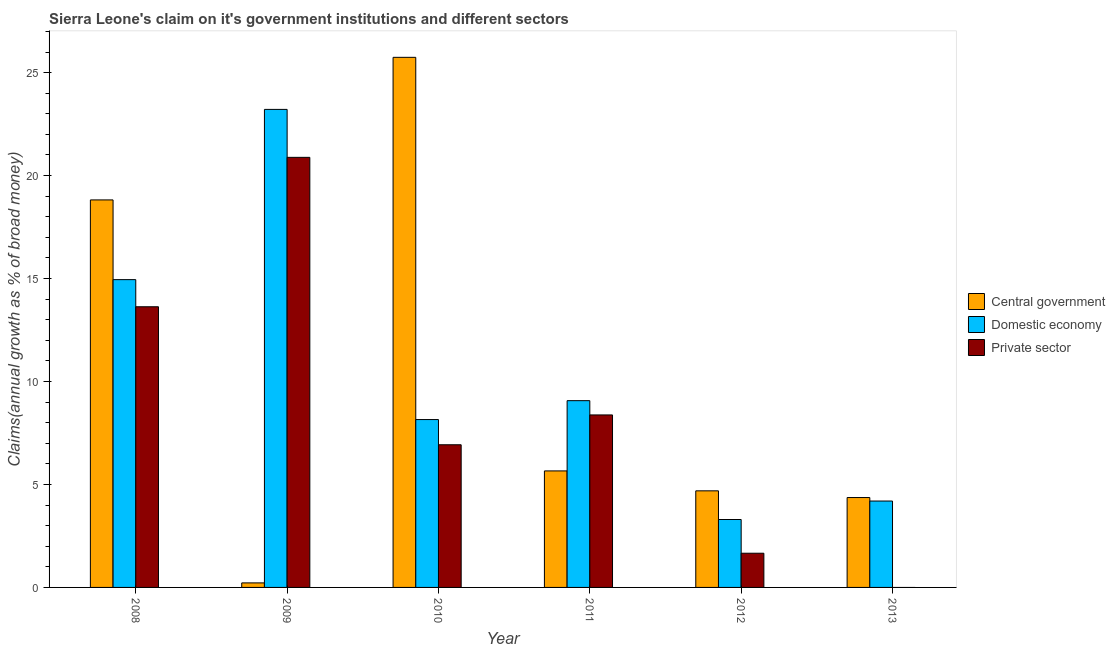How many different coloured bars are there?
Offer a terse response. 3. Are the number of bars per tick equal to the number of legend labels?
Offer a very short reply. No. Are the number of bars on each tick of the X-axis equal?
Your answer should be compact. No. How many bars are there on the 5th tick from the left?
Your answer should be compact. 3. How many bars are there on the 4th tick from the right?
Provide a succinct answer. 3. What is the label of the 3rd group of bars from the left?
Your answer should be very brief. 2010. What is the percentage of claim on the domestic economy in 2011?
Ensure brevity in your answer.  9.07. Across all years, what is the maximum percentage of claim on the central government?
Provide a short and direct response. 25.74. Across all years, what is the minimum percentage of claim on the central government?
Offer a terse response. 0.22. In which year was the percentage of claim on the domestic economy maximum?
Your answer should be very brief. 2009. What is the total percentage of claim on the private sector in the graph?
Ensure brevity in your answer.  51.48. What is the difference between the percentage of claim on the private sector in 2008 and that in 2011?
Your response must be concise. 5.25. What is the difference between the percentage of claim on the domestic economy in 2013 and the percentage of claim on the private sector in 2008?
Keep it short and to the point. -10.75. What is the average percentage of claim on the private sector per year?
Ensure brevity in your answer.  8.58. In how many years, is the percentage of claim on the private sector greater than 9 %?
Offer a very short reply. 2. What is the ratio of the percentage of claim on the domestic economy in 2011 to that in 2013?
Your answer should be very brief. 2.16. Is the percentage of claim on the central government in 2008 less than that in 2009?
Your answer should be very brief. No. What is the difference between the highest and the second highest percentage of claim on the domestic economy?
Your answer should be very brief. 8.27. What is the difference between the highest and the lowest percentage of claim on the central government?
Make the answer very short. 25.52. In how many years, is the percentage of claim on the central government greater than the average percentage of claim on the central government taken over all years?
Offer a terse response. 2. How many bars are there?
Your response must be concise. 17. Are the values on the major ticks of Y-axis written in scientific E-notation?
Provide a short and direct response. No. Does the graph contain grids?
Ensure brevity in your answer.  No. Where does the legend appear in the graph?
Your answer should be very brief. Center right. How many legend labels are there?
Offer a very short reply. 3. What is the title of the graph?
Your response must be concise. Sierra Leone's claim on it's government institutions and different sectors. What is the label or title of the Y-axis?
Offer a very short reply. Claims(annual growth as % of broad money). What is the Claims(annual growth as % of broad money) of Central government in 2008?
Make the answer very short. 18.82. What is the Claims(annual growth as % of broad money) in Domestic economy in 2008?
Your answer should be compact. 14.95. What is the Claims(annual growth as % of broad money) of Private sector in 2008?
Your answer should be very brief. 13.63. What is the Claims(annual growth as % of broad money) in Central government in 2009?
Ensure brevity in your answer.  0.22. What is the Claims(annual growth as % of broad money) of Domestic economy in 2009?
Provide a short and direct response. 23.21. What is the Claims(annual growth as % of broad money) in Private sector in 2009?
Provide a short and direct response. 20.88. What is the Claims(annual growth as % of broad money) in Central government in 2010?
Your response must be concise. 25.74. What is the Claims(annual growth as % of broad money) of Domestic economy in 2010?
Offer a very short reply. 8.15. What is the Claims(annual growth as % of broad money) of Private sector in 2010?
Make the answer very short. 6.93. What is the Claims(annual growth as % of broad money) of Central government in 2011?
Provide a succinct answer. 5.66. What is the Claims(annual growth as % of broad money) in Domestic economy in 2011?
Offer a terse response. 9.07. What is the Claims(annual growth as % of broad money) of Private sector in 2011?
Your response must be concise. 8.38. What is the Claims(annual growth as % of broad money) of Central government in 2012?
Offer a very short reply. 4.69. What is the Claims(annual growth as % of broad money) of Domestic economy in 2012?
Keep it short and to the point. 3.3. What is the Claims(annual growth as % of broad money) of Private sector in 2012?
Your answer should be compact. 1.66. What is the Claims(annual growth as % of broad money) of Central government in 2013?
Your answer should be very brief. 4.36. What is the Claims(annual growth as % of broad money) of Domestic economy in 2013?
Provide a short and direct response. 4.2. Across all years, what is the maximum Claims(annual growth as % of broad money) in Central government?
Give a very brief answer. 25.74. Across all years, what is the maximum Claims(annual growth as % of broad money) in Domestic economy?
Provide a succinct answer. 23.21. Across all years, what is the maximum Claims(annual growth as % of broad money) of Private sector?
Offer a terse response. 20.88. Across all years, what is the minimum Claims(annual growth as % of broad money) of Central government?
Keep it short and to the point. 0.22. Across all years, what is the minimum Claims(annual growth as % of broad money) of Domestic economy?
Give a very brief answer. 3.3. Across all years, what is the minimum Claims(annual growth as % of broad money) of Private sector?
Provide a short and direct response. 0. What is the total Claims(annual growth as % of broad money) in Central government in the graph?
Offer a terse response. 59.49. What is the total Claims(annual growth as % of broad money) of Domestic economy in the graph?
Provide a short and direct response. 62.88. What is the total Claims(annual growth as % of broad money) of Private sector in the graph?
Give a very brief answer. 51.48. What is the difference between the Claims(annual growth as % of broad money) in Central government in 2008 and that in 2009?
Your answer should be very brief. 18.6. What is the difference between the Claims(annual growth as % of broad money) in Domestic economy in 2008 and that in 2009?
Ensure brevity in your answer.  -8.27. What is the difference between the Claims(annual growth as % of broad money) of Private sector in 2008 and that in 2009?
Ensure brevity in your answer.  -7.25. What is the difference between the Claims(annual growth as % of broad money) of Central government in 2008 and that in 2010?
Provide a short and direct response. -6.92. What is the difference between the Claims(annual growth as % of broad money) of Domestic economy in 2008 and that in 2010?
Make the answer very short. 6.8. What is the difference between the Claims(annual growth as % of broad money) in Private sector in 2008 and that in 2010?
Your answer should be compact. 6.7. What is the difference between the Claims(annual growth as % of broad money) in Central government in 2008 and that in 2011?
Make the answer very short. 13.16. What is the difference between the Claims(annual growth as % of broad money) of Domestic economy in 2008 and that in 2011?
Your answer should be compact. 5.88. What is the difference between the Claims(annual growth as % of broad money) of Private sector in 2008 and that in 2011?
Provide a succinct answer. 5.25. What is the difference between the Claims(annual growth as % of broad money) of Central government in 2008 and that in 2012?
Provide a succinct answer. 14.13. What is the difference between the Claims(annual growth as % of broad money) in Domestic economy in 2008 and that in 2012?
Give a very brief answer. 11.65. What is the difference between the Claims(annual growth as % of broad money) of Private sector in 2008 and that in 2012?
Your response must be concise. 11.97. What is the difference between the Claims(annual growth as % of broad money) in Central government in 2008 and that in 2013?
Your answer should be compact. 14.45. What is the difference between the Claims(annual growth as % of broad money) of Domestic economy in 2008 and that in 2013?
Provide a succinct answer. 10.75. What is the difference between the Claims(annual growth as % of broad money) in Central government in 2009 and that in 2010?
Offer a very short reply. -25.52. What is the difference between the Claims(annual growth as % of broad money) of Domestic economy in 2009 and that in 2010?
Provide a succinct answer. 15.06. What is the difference between the Claims(annual growth as % of broad money) in Private sector in 2009 and that in 2010?
Ensure brevity in your answer.  13.96. What is the difference between the Claims(annual growth as % of broad money) in Central government in 2009 and that in 2011?
Keep it short and to the point. -5.44. What is the difference between the Claims(annual growth as % of broad money) in Domestic economy in 2009 and that in 2011?
Ensure brevity in your answer.  14.14. What is the difference between the Claims(annual growth as % of broad money) in Private sector in 2009 and that in 2011?
Give a very brief answer. 12.51. What is the difference between the Claims(annual growth as % of broad money) of Central government in 2009 and that in 2012?
Offer a very short reply. -4.47. What is the difference between the Claims(annual growth as % of broad money) in Domestic economy in 2009 and that in 2012?
Offer a terse response. 19.92. What is the difference between the Claims(annual growth as % of broad money) in Private sector in 2009 and that in 2012?
Keep it short and to the point. 19.22. What is the difference between the Claims(annual growth as % of broad money) of Central government in 2009 and that in 2013?
Give a very brief answer. -4.14. What is the difference between the Claims(annual growth as % of broad money) in Domestic economy in 2009 and that in 2013?
Provide a succinct answer. 19.02. What is the difference between the Claims(annual growth as % of broad money) of Central government in 2010 and that in 2011?
Provide a short and direct response. 20.08. What is the difference between the Claims(annual growth as % of broad money) of Domestic economy in 2010 and that in 2011?
Provide a short and direct response. -0.92. What is the difference between the Claims(annual growth as % of broad money) in Private sector in 2010 and that in 2011?
Offer a terse response. -1.45. What is the difference between the Claims(annual growth as % of broad money) of Central government in 2010 and that in 2012?
Give a very brief answer. 21.05. What is the difference between the Claims(annual growth as % of broad money) of Domestic economy in 2010 and that in 2012?
Give a very brief answer. 4.85. What is the difference between the Claims(annual growth as % of broad money) in Private sector in 2010 and that in 2012?
Keep it short and to the point. 5.27. What is the difference between the Claims(annual growth as % of broad money) of Central government in 2010 and that in 2013?
Offer a terse response. 21.38. What is the difference between the Claims(annual growth as % of broad money) in Domestic economy in 2010 and that in 2013?
Provide a short and direct response. 3.96. What is the difference between the Claims(annual growth as % of broad money) of Central government in 2011 and that in 2012?
Your response must be concise. 0.97. What is the difference between the Claims(annual growth as % of broad money) in Domestic economy in 2011 and that in 2012?
Give a very brief answer. 5.77. What is the difference between the Claims(annual growth as % of broad money) of Private sector in 2011 and that in 2012?
Keep it short and to the point. 6.72. What is the difference between the Claims(annual growth as % of broad money) in Central government in 2011 and that in 2013?
Offer a very short reply. 1.29. What is the difference between the Claims(annual growth as % of broad money) in Domestic economy in 2011 and that in 2013?
Offer a very short reply. 4.87. What is the difference between the Claims(annual growth as % of broad money) of Central government in 2012 and that in 2013?
Provide a succinct answer. 0.33. What is the difference between the Claims(annual growth as % of broad money) in Domestic economy in 2012 and that in 2013?
Your answer should be very brief. -0.9. What is the difference between the Claims(annual growth as % of broad money) of Central government in 2008 and the Claims(annual growth as % of broad money) of Domestic economy in 2009?
Your answer should be very brief. -4.4. What is the difference between the Claims(annual growth as % of broad money) of Central government in 2008 and the Claims(annual growth as % of broad money) of Private sector in 2009?
Keep it short and to the point. -2.07. What is the difference between the Claims(annual growth as % of broad money) of Domestic economy in 2008 and the Claims(annual growth as % of broad money) of Private sector in 2009?
Offer a terse response. -5.94. What is the difference between the Claims(annual growth as % of broad money) of Central government in 2008 and the Claims(annual growth as % of broad money) of Domestic economy in 2010?
Ensure brevity in your answer.  10.67. What is the difference between the Claims(annual growth as % of broad money) of Central government in 2008 and the Claims(annual growth as % of broad money) of Private sector in 2010?
Your answer should be compact. 11.89. What is the difference between the Claims(annual growth as % of broad money) in Domestic economy in 2008 and the Claims(annual growth as % of broad money) in Private sector in 2010?
Give a very brief answer. 8.02. What is the difference between the Claims(annual growth as % of broad money) in Central government in 2008 and the Claims(annual growth as % of broad money) in Domestic economy in 2011?
Provide a succinct answer. 9.75. What is the difference between the Claims(annual growth as % of broad money) of Central government in 2008 and the Claims(annual growth as % of broad money) of Private sector in 2011?
Provide a succinct answer. 10.44. What is the difference between the Claims(annual growth as % of broad money) of Domestic economy in 2008 and the Claims(annual growth as % of broad money) of Private sector in 2011?
Provide a short and direct response. 6.57. What is the difference between the Claims(annual growth as % of broad money) of Central government in 2008 and the Claims(annual growth as % of broad money) of Domestic economy in 2012?
Your response must be concise. 15.52. What is the difference between the Claims(annual growth as % of broad money) of Central government in 2008 and the Claims(annual growth as % of broad money) of Private sector in 2012?
Provide a short and direct response. 17.16. What is the difference between the Claims(annual growth as % of broad money) of Domestic economy in 2008 and the Claims(annual growth as % of broad money) of Private sector in 2012?
Ensure brevity in your answer.  13.29. What is the difference between the Claims(annual growth as % of broad money) of Central government in 2008 and the Claims(annual growth as % of broad money) of Domestic economy in 2013?
Provide a short and direct response. 14.62. What is the difference between the Claims(annual growth as % of broad money) in Central government in 2009 and the Claims(annual growth as % of broad money) in Domestic economy in 2010?
Your answer should be very brief. -7.93. What is the difference between the Claims(annual growth as % of broad money) in Central government in 2009 and the Claims(annual growth as % of broad money) in Private sector in 2010?
Ensure brevity in your answer.  -6.71. What is the difference between the Claims(annual growth as % of broad money) in Domestic economy in 2009 and the Claims(annual growth as % of broad money) in Private sector in 2010?
Your answer should be compact. 16.29. What is the difference between the Claims(annual growth as % of broad money) of Central government in 2009 and the Claims(annual growth as % of broad money) of Domestic economy in 2011?
Offer a terse response. -8.85. What is the difference between the Claims(annual growth as % of broad money) in Central government in 2009 and the Claims(annual growth as % of broad money) in Private sector in 2011?
Offer a terse response. -8.16. What is the difference between the Claims(annual growth as % of broad money) of Domestic economy in 2009 and the Claims(annual growth as % of broad money) of Private sector in 2011?
Ensure brevity in your answer.  14.84. What is the difference between the Claims(annual growth as % of broad money) of Central government in 2009 and the Claims(annual growth as % of broad money) of Domestic economy in 2012?
Your answer should be compact. -3.08. What is the difference between the Claims(annual growth as % of broad money) in Central government in 2009 and the Claims(annual growth as % of broad money) in Private sector in 2012?
Your answer should be compact. -1.44. What is the difference between the Claims(annual growth as % of broad money) in Domestic economy in 2009 and the Claims(annual growth as % of broad money) in Private sector in 2012?
Your response must be concise. 21.55. What is the difference between the Claims(annual growth as % of broad money) of Central government in 2009 and the Claims(annual growth as % of broad money) of Domestic economy in 2013?
Offer a very short reply. -3.98. What is the difference between the Claims(annual growth as % of broad money) in Central government in 2010 and the Claims(annual growth as % of broad money) in Domestic economy in 2011?
Offer a terse response. 16.67. What is the difference between the Claims(annual growth as % of broad money) in Central government in 2010 and the Claims(annual growth as % of broad money) in Private sector in 2011?
Offer a terse response. 17.37. What is the difference between the Claims(annual growth as % of broad money) of Domestic economy in 2010 and the Claims(annual growth as % of broad money) of Private sector in 2011?
Ensure brevity in your answer.  -0.22. What is the difference between the Claims(annual growth as % of broad money) of Central government in 2010 and the Claims(annual growth as % of broad money) of Domestic economy in 2012?
Your answer should be compact. 22.44. What is the difference between the Claims(annual growth as % of broad money) of Central government in 2010 and the Claims(annual growth as % of broad money) of Private sector in 2012?
Your response must be concise. 24.08. What is the difference between the Claims(annual growth as % of broad money) of Domestic economy in 2010 and the Claims(annual growth as % of broad money) of Private sector in 2012?
Provide a succinct answer. 6.49. What is the difference between the Claims(annual growth as % of broad money) of Central government in 2010 and the Claims(annual growth as % of broad money) of Domestic economy in 2013?
Keep it short and to the point. 21.55. What is the difference between the Claims(annual growth as % of broad money) in Central government in 2011 and the Claims(annual growth as % of broad money) in Domestic economy in 2012?
Provide a succinct answer. 2.36. What is the difference between the Claims(annual growth as % of broad money) in Central government in 2011 and the Claims(annual growth as % of broad money) in Private sector in 2012?
Provide a succinct answer. 4. What is the difference between the Claims(annual growth as % of broad money) of Domestic economy in 2011 and the Claims(annual growth as % of broad money) of Private sector in 2012?
Your answer should be very brief. 7.41. What is the difference between the Claims(annual growth as % of broad money) in Central government in 2011 and the Claims(annual growth as % of broad money) in Domestic economy in 2013?
Provide a short and direct response. 1.46. What is the difference between the Claims(annual growth as % of broad money) in Central government in 2012 and the Claims(annual growth as % of broad money) in Domestic economy in 2013?
Your response must be concise. 0.5. What is the average Claims(annual growth as % of broad money) in Central government per year?
Ensure brevity in your answer.  9.92. What is the average Claims(annual growth as % of broad money) of Domestic economy per year?
Offer a very short reply. 10.48. What is the average Claims(annual growth as % of broad money) of Private sector per year?
Ensure brevity in your answer.  8.58. In the year 2008, what is the difference between the Claims(annual growth as % of broad money) of Central government and Claims(annual growth as % of broad money) of Domestic economy?
Provide a succinct answer. 3.87. In the year 2008, what is the difference between the Claims(annual growth as % of broad money) of Central government and Claims(annual growth as % of broad money) of Private sector?
Provide a short and direct response. 5.19. In the year 2008, what is the difference between the Claims(annual growth as % of broad money) of Domestic economy and Claims(annual growth as % of broad money) of Private sector?
Your answer should be compact. 1.32. In the year 2009, what is the difference between the Claims(annual growth as % of broad money) in Central government and Claims(annual growth as % of broad money) in Domestic economy?
Your response must be concise. -22.99. In the year 2009, what is the difference between the Claims(annual growth as % of broad money) of Central government and Claims(annual growth as % of broad money) of Private sector?
Keep it short and to the point. -20.66. In the year 2009, what is the difference between the Claims(annual growth as % of broad money) in Domestic economy and Claims(annual growth as % of broad money) in Private sector?
Make the answer very short. 2.33. In the year 2010, what is the difference between the Claims(annual growth as % of broad money) in Central government and Claims(annual growth as % of broad money) in Domestic economy?
Ensure brevity in your answer.  17.59. In the year 2010, what is the difference between the Claims(annual growth as % of broad money) of Central government and Claims(annual growth as % of broad money) of Private sector?
Keep it short and to the point. 18.81. In the year 2010, what is the difference between the Claims(annual growth as % of broad money) in Domestic economy and Claims(annual growth as % of broad money) in Private sector?
Ensure brevity in your answer.  1.22. In the year 2011, what is the difference between the Claims(annual growth as % of broad money) of Central government and Claims(annual growth as % of broad money) of Domestic economy?
Provide a short and direct response. -3.41. In the year 2011, what is the difference between the Claims(annual growth as % of broad money) in Central government and Claims(annual growth as % of broad money) in Private sector?
Your answer should be very brief. -2.72. In the year 2011, what is the difference between the Claims(annual growth as % of broad money) in Domestic economy and Claims(annual growth as % of broad money) in Private sector?
Give a very brief answer. 0.69. In the year 2012, what is the difference between the Claims(annual growth as % of broad money) in Central government and Claims(annual growth as % of broad money) in Domestic economy?
Your answer should be very brief. 1.39. In the year 2012, what is the difference between the Claims(annual growth as % of broad money) of Central government and Claims(annual growth as % of broad money) of Private sector?
Keep it short and to the point. 3.03. In the year 2012, what is the difference between the Claims(annual growth as % of broad money) of Domestic economy and Claims(annual growth as % of broad money) of Private sector?
Your response must be concise. 1.64. In the year 2013, what is the difference between the Claims(annual growth as % of broad money) in Central government and Claims(annual growth as % of broad money) in Domestic economy?
Ensure brevity in your answer.  0.17. What is the ratio of the Claims(annual growth as % of broad money) of Central government in 2008 to that in 2009?
Provide a short and direct response. 85.49. What is the ratio of the Claims(annual growth as % of broad money) in Domestic economy in 2008 to that in 2009?
Ensure brevity in your answer.  0.64. What is the ratio of the Claims(annual growth as % of broad money) of Private sector in 2008 to that in 2009?
Keep it short and to the point. 0.65. What is the ratio of the Claims(annual growth as % of broad money) of Central government in 2008 to that in 2010?
Your response must be concise. 0.73. What is the ratio of the Claims(annual growth as % of broad money) in Domestic economy in 2008 to that in 2010?
Provide a succinct answer. 1.83. What is the ratio of the Claims(annual growth as % of broad money) of Private sector in 2008 to that in 2010?
Offer a very short reply. 1.97. What is the ratio of the Claims(annual growth as % of broad money) in Central government in 2008 to that in 2011?
Your answer should be very brief. 3.33. What is the ratio of the Claims(annual growth as % of broad money) in Domestic economy in 2008 to that in 2011?
Your answer should be compact. 1.65. What is the ratio of the Claims(annual growth as % of broad money) of Private sector in 2008 to that in 2011?
Ensure brevity in your answer.  1.63. What is the ratio of the Claims(annual growth as % of broad money) in Central government in 2008 to that in 2012?
Give a very brief answer. 4.01. What is the ratio of the Claims(annual growth as % of broad money) in Domestic economy in 2008 to that in 2012?
Your response must be concise. 4.53. What is the ratio of the Claims(annual growth as % of broad money) in Private sector in 2008 to that in 2012?
Provide a succinct answer. 8.21. What is the ratio of the Claims(annual growth as % of broad money) of Central government in 2008 to that in 2013?
Provide a short and direct response. 4.31. What is the ratio of the Claims(annual growth as % of broad money) in Domestic economy in 2008 to that in 2013?
Offer a very short reply. 3.56. What is the ratio of the Claims(annual growth as % of broad money) in Central government in 2009 to that in 2010?
Provide a succinct answer. 0.01. What is the ratio of the Claims(annual growth as % of broad money) of Domestic economy in 2009 to that in 2010?
Keep it short and to the point. 2.85. What is the ratio of the Claims(annual growth as % of broad money) of Private sector in 2009 to that in 2010?
Keep it short and to the point. 3.01. What is the ratio of the Claims(annual growth as % of broad money) in Central government in 2009 to that in 2011?
Give a very brief answer. 0.04. What is the ratio of the Claims(annual growth as % of broad money) of Domestic economy in 2009 to that in 2011?
Ensure brevity in your answer.  2.56. What is the ratio of the Claims(annual growth as % of broad money) of Private sector in 2009 to that in 2011?
Offer a terse response. 2.49. What is the ratio of the Claims(annual growth as % of broad money) of Central government in 2009 to that in 2012?
Provide a succinct answer. 0.05. What is the ratio of the Claims(annual growth as % of broad money) of Domestic economy in 2009 to that in 2012?
Provide a short and direct response. 7.04. What is the ratio of the Claims(annual growth as % of broad money) of Private sector in 2009 to that in 2012?
Keep it short and to the point. 12.57. What is the ratio of the Claims(annual growth as % of broad money) of Central government in 2009 to that in 2013?
Offer a terse response. 0.05. What is the ratio of the Claims(annual growth as % of broad money) of Domestic economy in 2009 to that in 2013?
Offer a terse response. 5.53. What is the ratio of the Claims(annual growth as % of broad money) in Central government in 2010 to that in 2011?
Provide a succinct answer. 4.55. What is the ratio of the Claims(annual growth as % of broad money) in Domestic economy in 2010 to that in 2011?
Offer a terse response. 0.9. What is the ratio of the Claims(annual growth as % of broad money) of Private sector in 2010 to that in 2011?
Offer a terse response. 0.83. What is the ratio of the Claims(annual growth as % of broad money) of Central government in 2010 to that in 2012?
Your answer should be very brief. 5.49. What is the ratio of the Claims(annual growth as % of broad money) of Domestic economy in 2010 to that in 2012?
Provide a short and direct response. 2.47. What is the ratio of the Claims(annual growth as % of broad money) of Private sector in 2010 to that in 2012?
Your answer should be very brief. 4.17. What is the ratio of the Claims(annual growth as % of broad money) in Central government in 2010 to that in 2013?
Make the answer very short. 5.9. What is the ratio of the Claims(annual growth as % of broad money) in Domestic economy in 2010 to that in 2013?
Your answer should be compact. 1.94. What is the ratio of the Claims(annual growth as % of broad money) of Central government in 2011 to that in 2012?
Ensure brevity in your answer.  1.21. What is the ratio of the Claims(annual growth as % of broad money) in Domestic economy in 2011 to that in 2012?
Keep it short and to the point. 2.75. What is the ratio of the Claims(annual growth as % of broad money) of Private sector in 2011 to that in 2012?
Your answer should be very brief. 5.04. What is the ratio of the Claims(annual growth as % of broad money) in Central government in 2011 to that in 2013?
Provide a succinct answer. 1.3. What is the ratio of the Claims(annual growth as % of broad money) in Domestic economy in 2011 to that in 2013?
Provide a succinct answer. 2.16. What is the ratio of the Claims(annual growth as % of broad money) in Central government in 2012 to that in 2013?
Your answer should be compact. 1.07. What is the ratio of the Claims(annual growth as % of broad money) in Domestic economy in 2012 to that in 2013?
Your answer should be very brief. 0.79. What is the difference between the highest and the second highest Claims(annual growth as % of broad money) of Central government?
Provide a succinct answer. 6.92. What is the difference between the highest and the second highest Claims(annual growth as % of broad money) in Domestic economy?
Your answer should be very brief. 8.27. What is the difference between the highest and the second highest Claims(annual growth as % of broad money) of Private sector?
Provide a short and direct response. 7.25. What is the difference between the highest and the lowest Claims(annual growth as % of broad money) in Central government?
Keep it short and to the point. 25.52. What is the difference between the highest and the lowest Claims(annual growth as % of broad money) in Domestic economy?
Provide a short and direct response. 19.92. What is the difference between the highest and the lowest Claims(annual growth as % of broad money) of Private sector?
Your response must be concise. 20.88. 